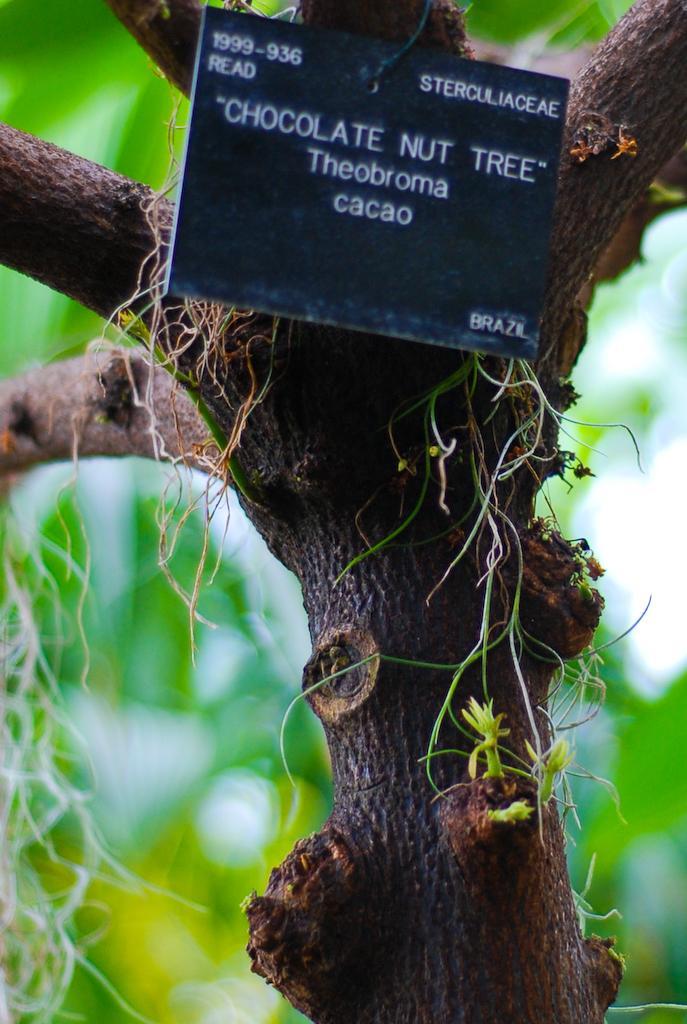Describe this image in one or two sentences. This image is taken outdoors. In the background there is a tree with green leaves. In the middle of the image there is a tree and there is a board with a text on it. 